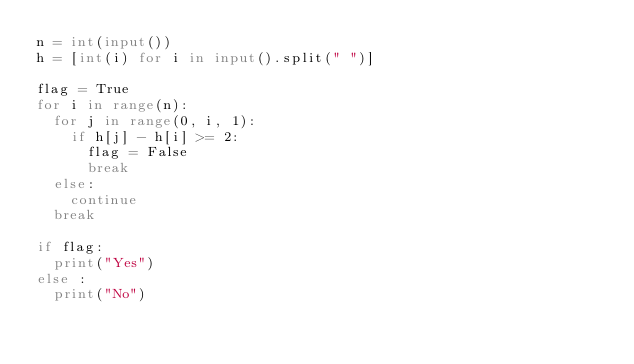<code> <loc_0><loc_0><loc_500><loc_500><_Python_>n = int(input())
h = [int(i) for i in input().split(" ")]

flag = True
for i in range(n):
  for j in range(0, i, 1):
    if h[j] - h[i] >= 2:
      flag = False
      break
  else:
    continue
  break

if flag:
  print("Yes")
else :
  print("No")</code> 